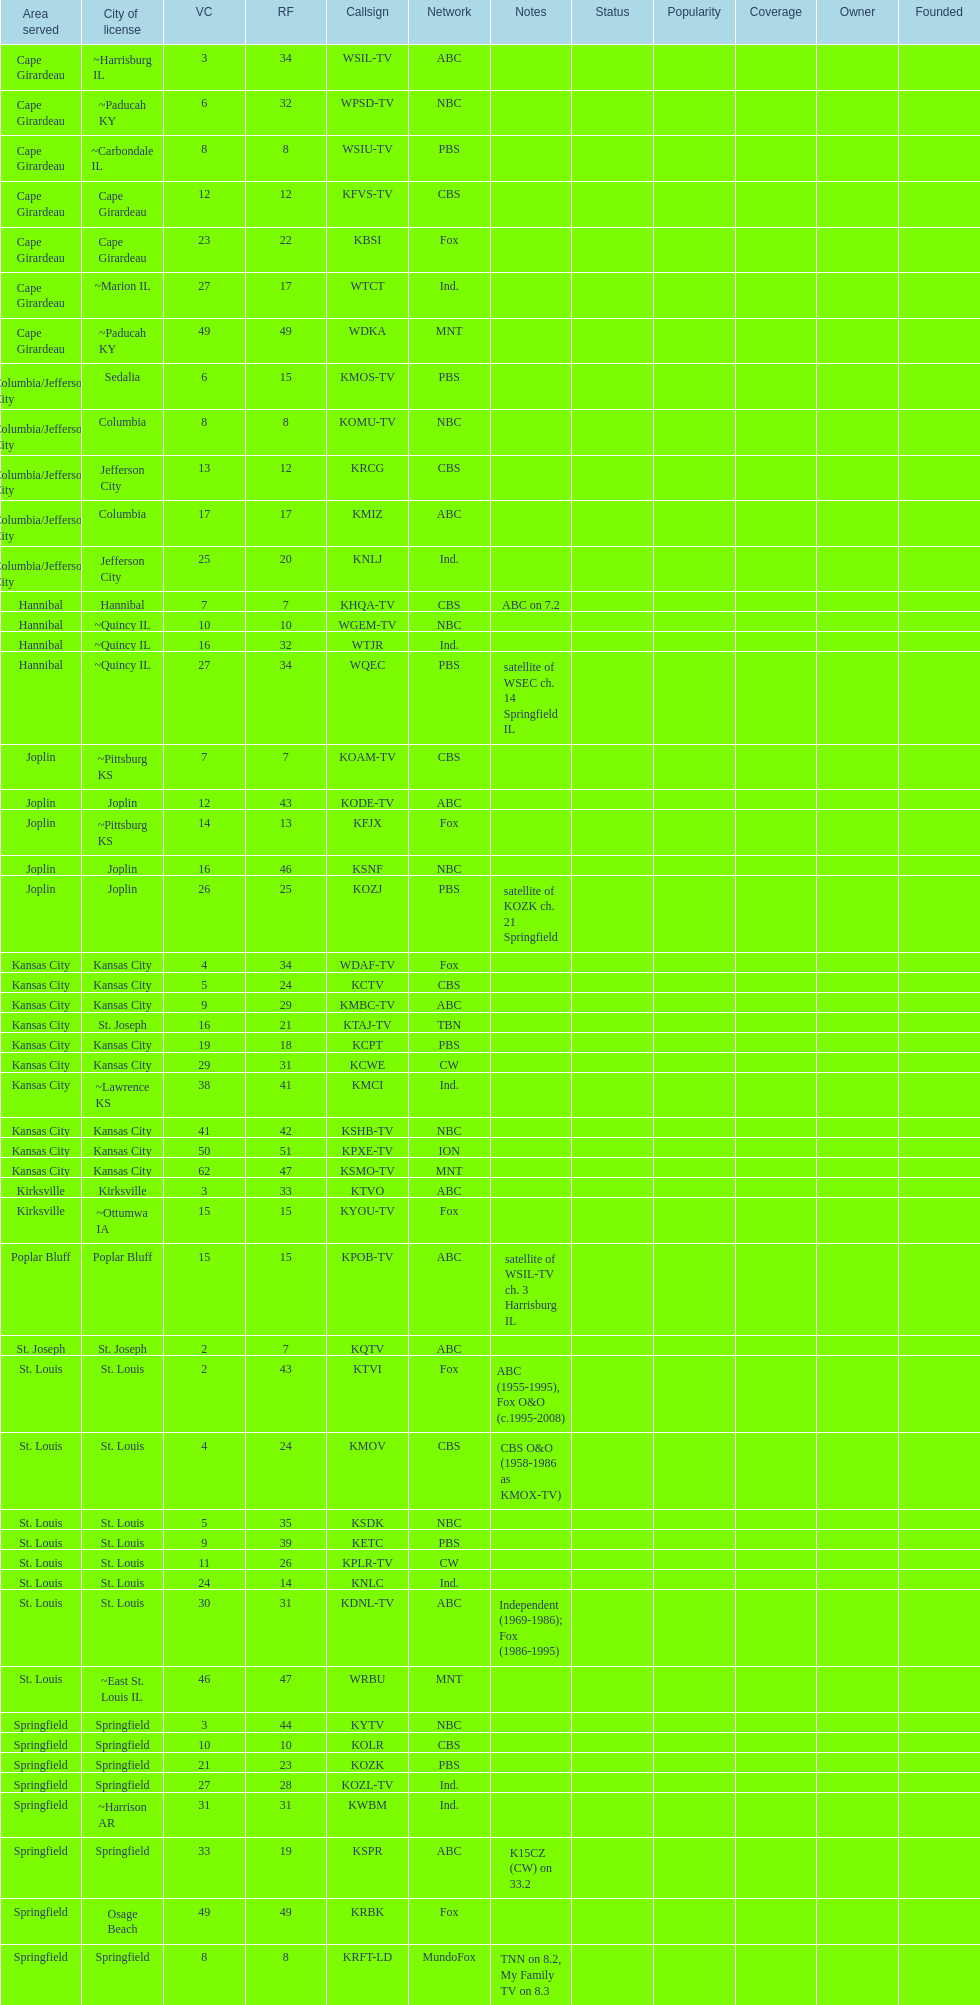What is the total number of cbs stations? 7. 